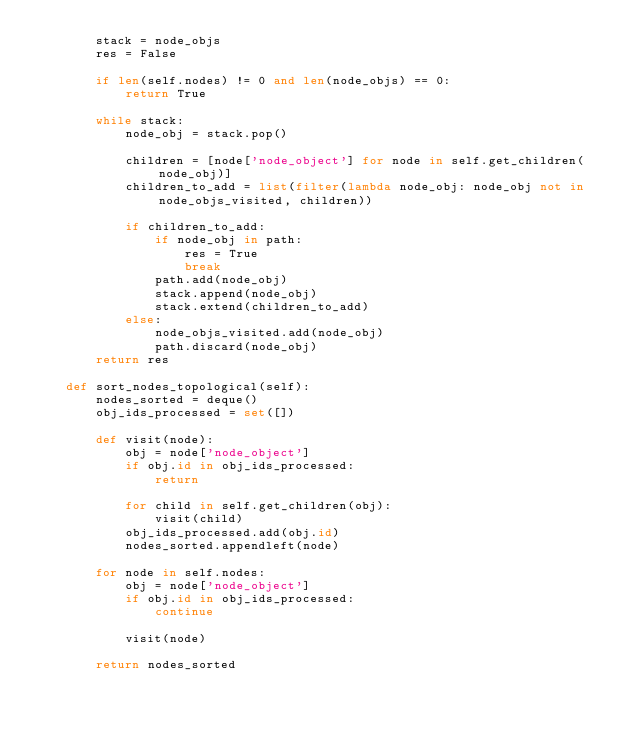<code> <loc_0><loc_0><loc_500><loc_500><_Python_>        stack = node_objs
        res = False

        if len(self.nodes) != 0 and len(node_objs) == 0:
            return True

        while stack:
            node_obj = stack.pop()

            children = [node['node_object'] for node in self.get_children(node_obj)]
            children_to_add = list(filter(lambda node_obj: node_obj not in node_objs_visited, children))

            if children_to_add:
                if node_obj in path:
                    res = True
                    break
                path.add(node_obj)
                stack.append(node_obj)
                stack.extend(children_to_add)
            else:
                node_objs_visited.add(node_obj)
                path.discard(node_obj)
        return res

    def sort_nodes_topological(self):
        nodes_sorted = deque()
        obj_ids_processed = set([])

        def visit(node):
            obj = node['node_object']
            if obj.id in obj_ids_processed:
                return

            for child in self.get_children(obj):
                visit(child)
            obj_ids_processed.add(obj.id)
            nodes_sorted.appendleft(node)

        for node in self.nodes:
            obj = node['node_object']
            if obj.id in obj_ids_processed:
                continue

            visit(node)

        return nodes_sorted
</code> 